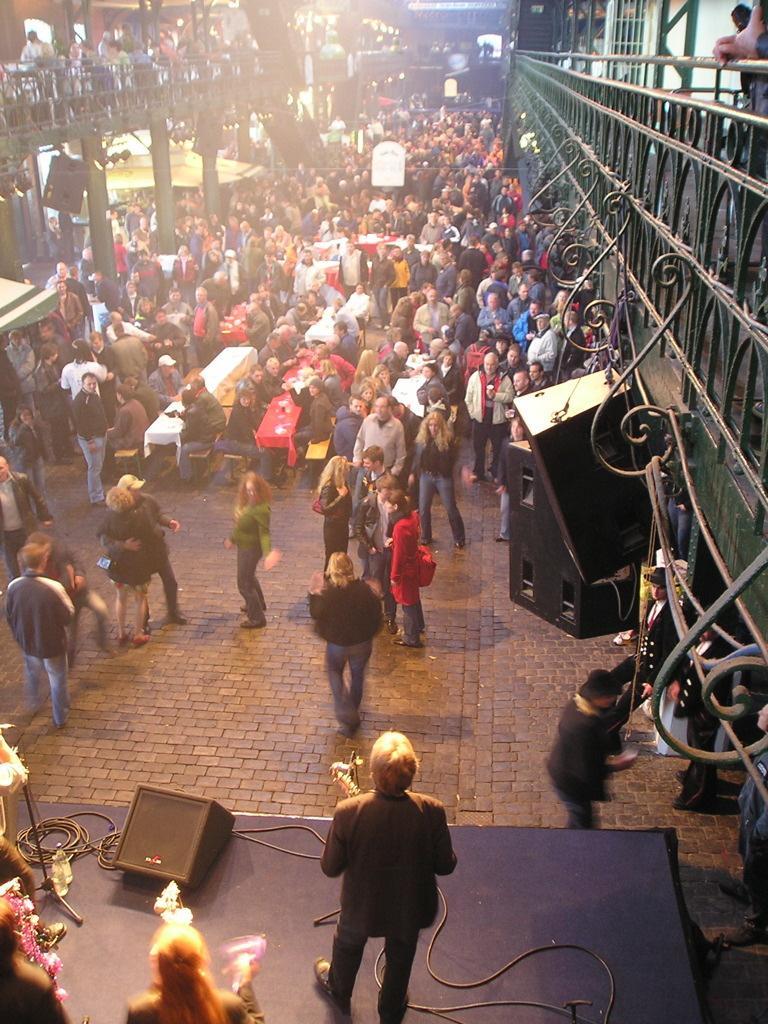How would you summarize this image in a sentence or two? In front of the image there are people standing on the stage and there are some objects on the stage. In front of the stage there are a few people standing and there are a few people sitting on the benches. In front of them there are tables. On top of it there are some objects. There are pillars, railings and there are a few other objects. On both right and left side of the image there are people standing on the building. 